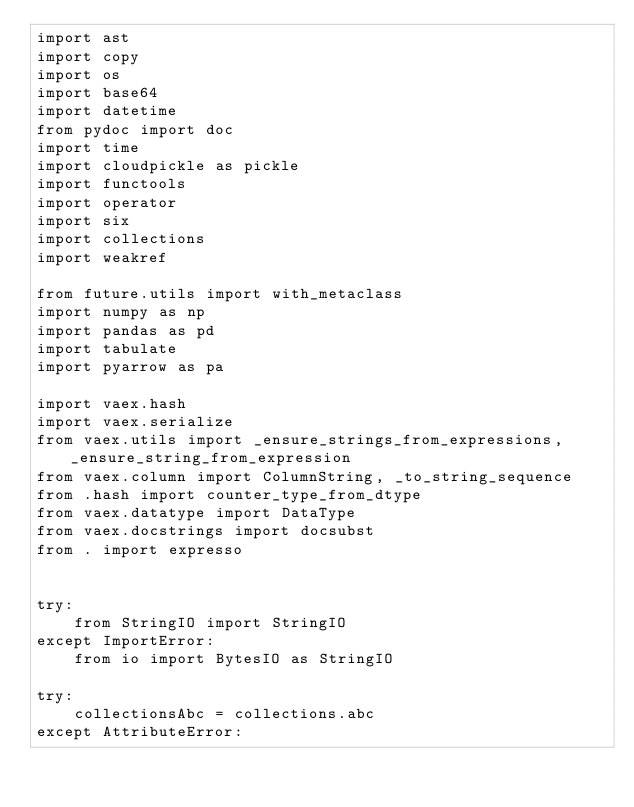<code> <loc_0><loc_0><loc_500><loc_500><_Python_>import ast
import copy
import os
import base64
import datetime
from pydoc import doc
import time
import cloudpickle as pickle
import functools
import operator
import six
import collections
import weakref

from future.utils import with_metaclass
import numpy as np
import pandas as pd
import tabulate
import pyarrow as pa

import vaex.hash
import vaex.serialize
from vaex.utils import _ensure_strings_from_expressions, _ensure_string_from_expression
from vaex.column import ColumnString, _to_string_sequence
from .hash import counter_type_from_dtype
from vaex.datatype import DataType
from vaex.docstrings import docsubst
from . import expresso


try:
    from StringIO import StringIO
except ImportError:
    from io import BytesIO as StringIO

try:
    collectionsAbc = collections.abc
except AttributeError:</code> 